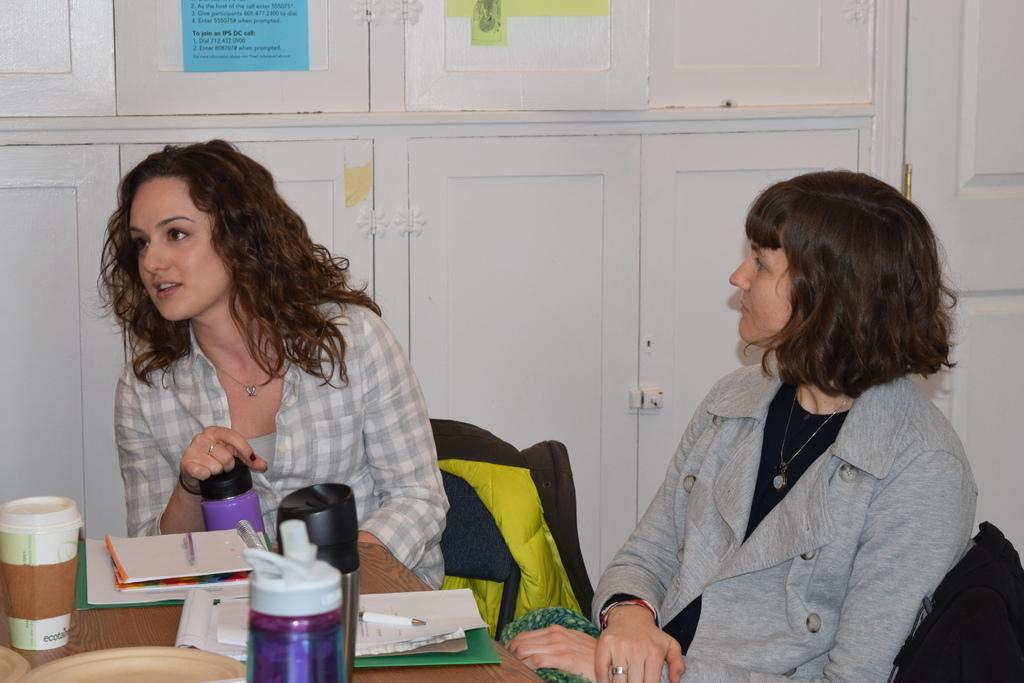How many women are in the image? There are two women in the image. What are the women doing in the image? The women are sitting on chairs. What is in front of the women? There is a table in front of the women. What items can be seen on the table? The table has bottles, papers, and a coffee mug on it. What is visible in the background of the image? There is a cupboard in the background of the image. How many trains can be seen in the image? There are no trains visible in the image. What are the boys doing in the image? There are no boys present in the image. 